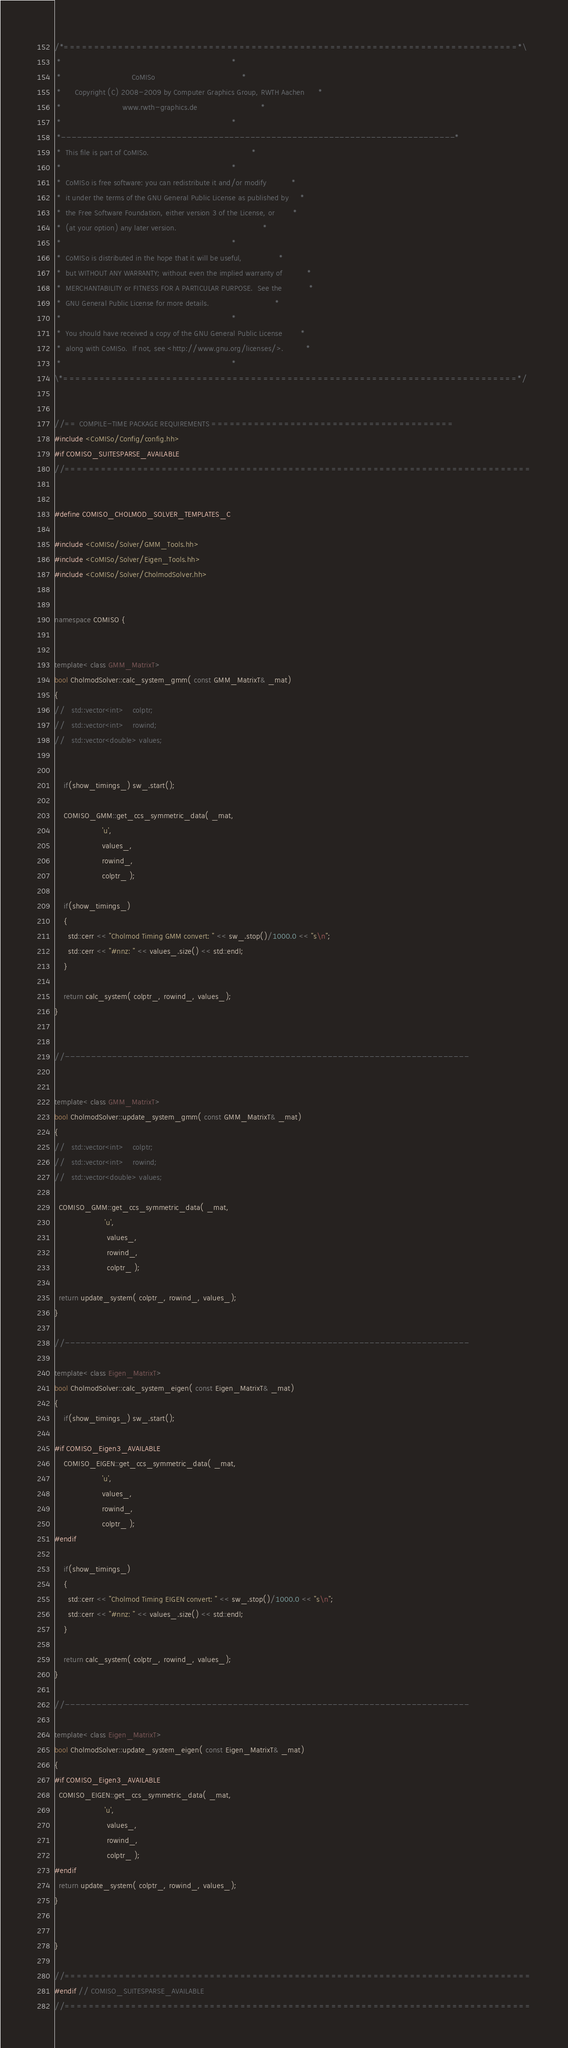Convert code to text. <code><loc_0><loc_0><loc_500><loc_500><_C++_>/*===========================================================================*\
 *                                                                           *
 *                               CoMISo                                      *
 *      Copyright (C) 2008-2009 by Computer Graphics Group, RWTH Aachen      *
 *                           www.rwth-graphics.de                            *
 *                                                                           *
 *---------------------------------------------------------------------------* 
 *  This file is part of CoMISo.                                             *
 *                                                                           *
 *  CoMISo is free software: you can redistribute it and/or modify           *
 *  it under the terms of the GNU General Public License as published by     *
 *  the Free Software Foundation, either version 3 of the License, or        *
 *  (at your option) any later version.                                      *
 *                                                                           *
 *  CoMISo is distributed in the hope that it will be useful,                *
 *  but WITHOUT ANY WARRANTY; without even the implied warranty of           *
 *  MERCHANTABILITY or FITNESS FOR A PARTICULAR PURPOSE.  See the            *
 *  GNU General Public License for more details.                             *
 *                                                                           *
 *  You should have received a copy of the GNU General Public License        *
 *  along with CoMISo.  If not, see <http://www.gnu.org/licenses/>.          *
 *                                                                           *
\*===========================================================================*/ 


//== COMPILE-TIME PACKAGE REQUIREMENTS ========================================
#include <CoMISo/Config/config.hh>
#if COMISO_SUITESPARSE_AVAILABLE
//=============================================================================


#define COMISO_CHOLMOD_SOLVER_TEMPLATES_C

#include <CoMISo/Solver/GMM_Tools.hh>
#include <CoMISo/Solver/Eigen_Tools.hh>
#include <CoMISo/Solver/CholmodSolver.hh>


namespace COMISO {


template< class GMM_MatrixT>
bool CholmodSolver::calc_system_gmm( const GMM_MatrixT& _mat)
{
//   std::vector<int>    colptr;
//   std::vector<int>    rowind;
//   std::vector<double> values;
    

    if(show_timings_) sw_.start();

    COMISO_GMM::get_ccs_symmetric_data( _mat,
					 'u',
					 values_, 
					 rowind_, 
					 colptr_ );
    
    if(show_timings_)
    {
      std::cerr << "Cholmod Timing GMM convert: " << sw_.stop()/1000.0 << "s\n";
      std::cerr << "#nnz: " << values_.size() << std::endl;
    }

    return calc_system( colptr_, rowind_, values_);
}
  

//-----------------------------------------------------------------------------


template< class GMM_MatrixT>
bool CholmodSolver::update_system_gmm( const GMM_MatrixT& _mat)
{
//   std::vector<int>    colptr;
//   std::vector<int>    rowind;
//   std::vector<double> values;
    
  COMISO_GMM::get_ccs_symmetric_data( _mat,
				      'u',
				       values_, 
				       rowind_, 
				       colptr_ );

  return update_system( colptr_, rowind_, values_);
}

//-----------------------------------------------------------------------------
  
template< class Eigen_MatrixT>
bool CholmodSolver::calc_system_eigen( const Eigen_MatrixT& _mat)
{
    if(show_timings_) sw_.start();

#if COMISO_Eigen3_AVAILABLE
    COMISO_EIGEN::get_ccs_symmetric_data( _mat,
					 'u',
					 values_, 
					 rowind_, 
					 colptr_ );
#endif
    
    if(show_timings_)
    {
      std::cerr << "Cholmod Timing EIGEN convert: " << sw_.stop()/1000.0 << "s\n";
      std::cerr << "#nnz: " << values_.size() << std::endl;
    }

    return calc_system( colptr_, rowind_, values_);
}
  
//-----------------------------------------------------------------------------

template< class Eigen_MatrixT>
bool CholmodSolver::update_system_eigen( const Eigen_MatrixT& _mat)
{
#if COMISO_Eigen3_AVAILABLE    
  COMISO_EIGEN::get_ccs_symmetric_data( _mat,
				      'u',
				       values_, 
				       rowind_, 
				       colptr_ );
#endif
  return update_system( colptr_, rowind_, values_);
}


}

//=============================================================================
#endif // COMISO_SUITESPARSE_AVAILABLE
//=============================================================================
</code> 